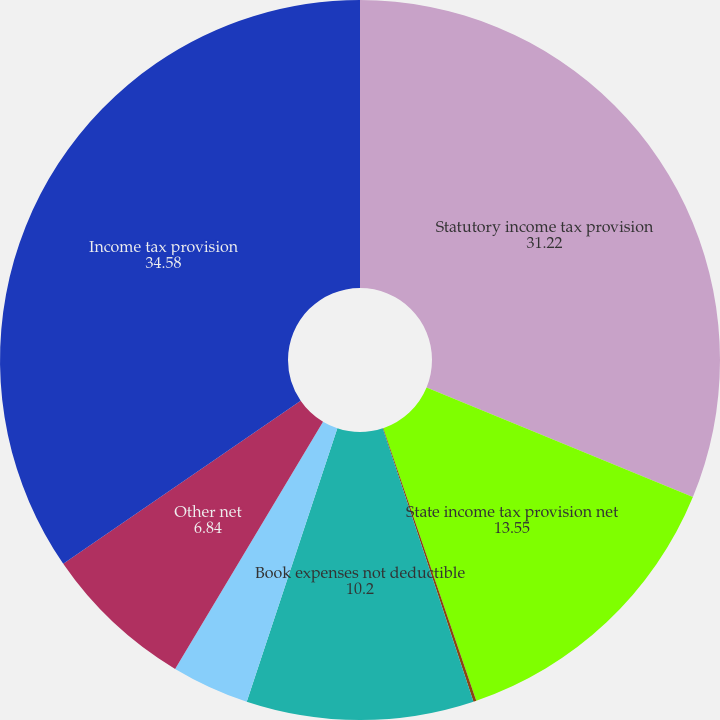<chart> <loc_0><loc_0><loc_500><loc_500><pie_chart><fcel>Statutory income tax provision<fcel>State income tax provision net<fcel>Foreign income taxes net of<fcel>Book expenses not deductible<fcel>Change in valuation allowance<fcel>Other net<fcel>Income tax provision<nl><fcel>31.22%<fcel>13.55%<fcel>0.13%<fcel>10.2%<fcel>3.49%<fcel>6.84%<fcel>34.58%<nl></chart> 